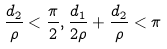<formula> <loc_0><loc_0><loc_500><loc_500>\frac { d _ { 2 } } { \rho } < \frac { \pi } { 2 } , \frac { d _ { 1 } } { 2 \rho } + \frac { d _ { 2 } } { \rho } < \pi</formula> 